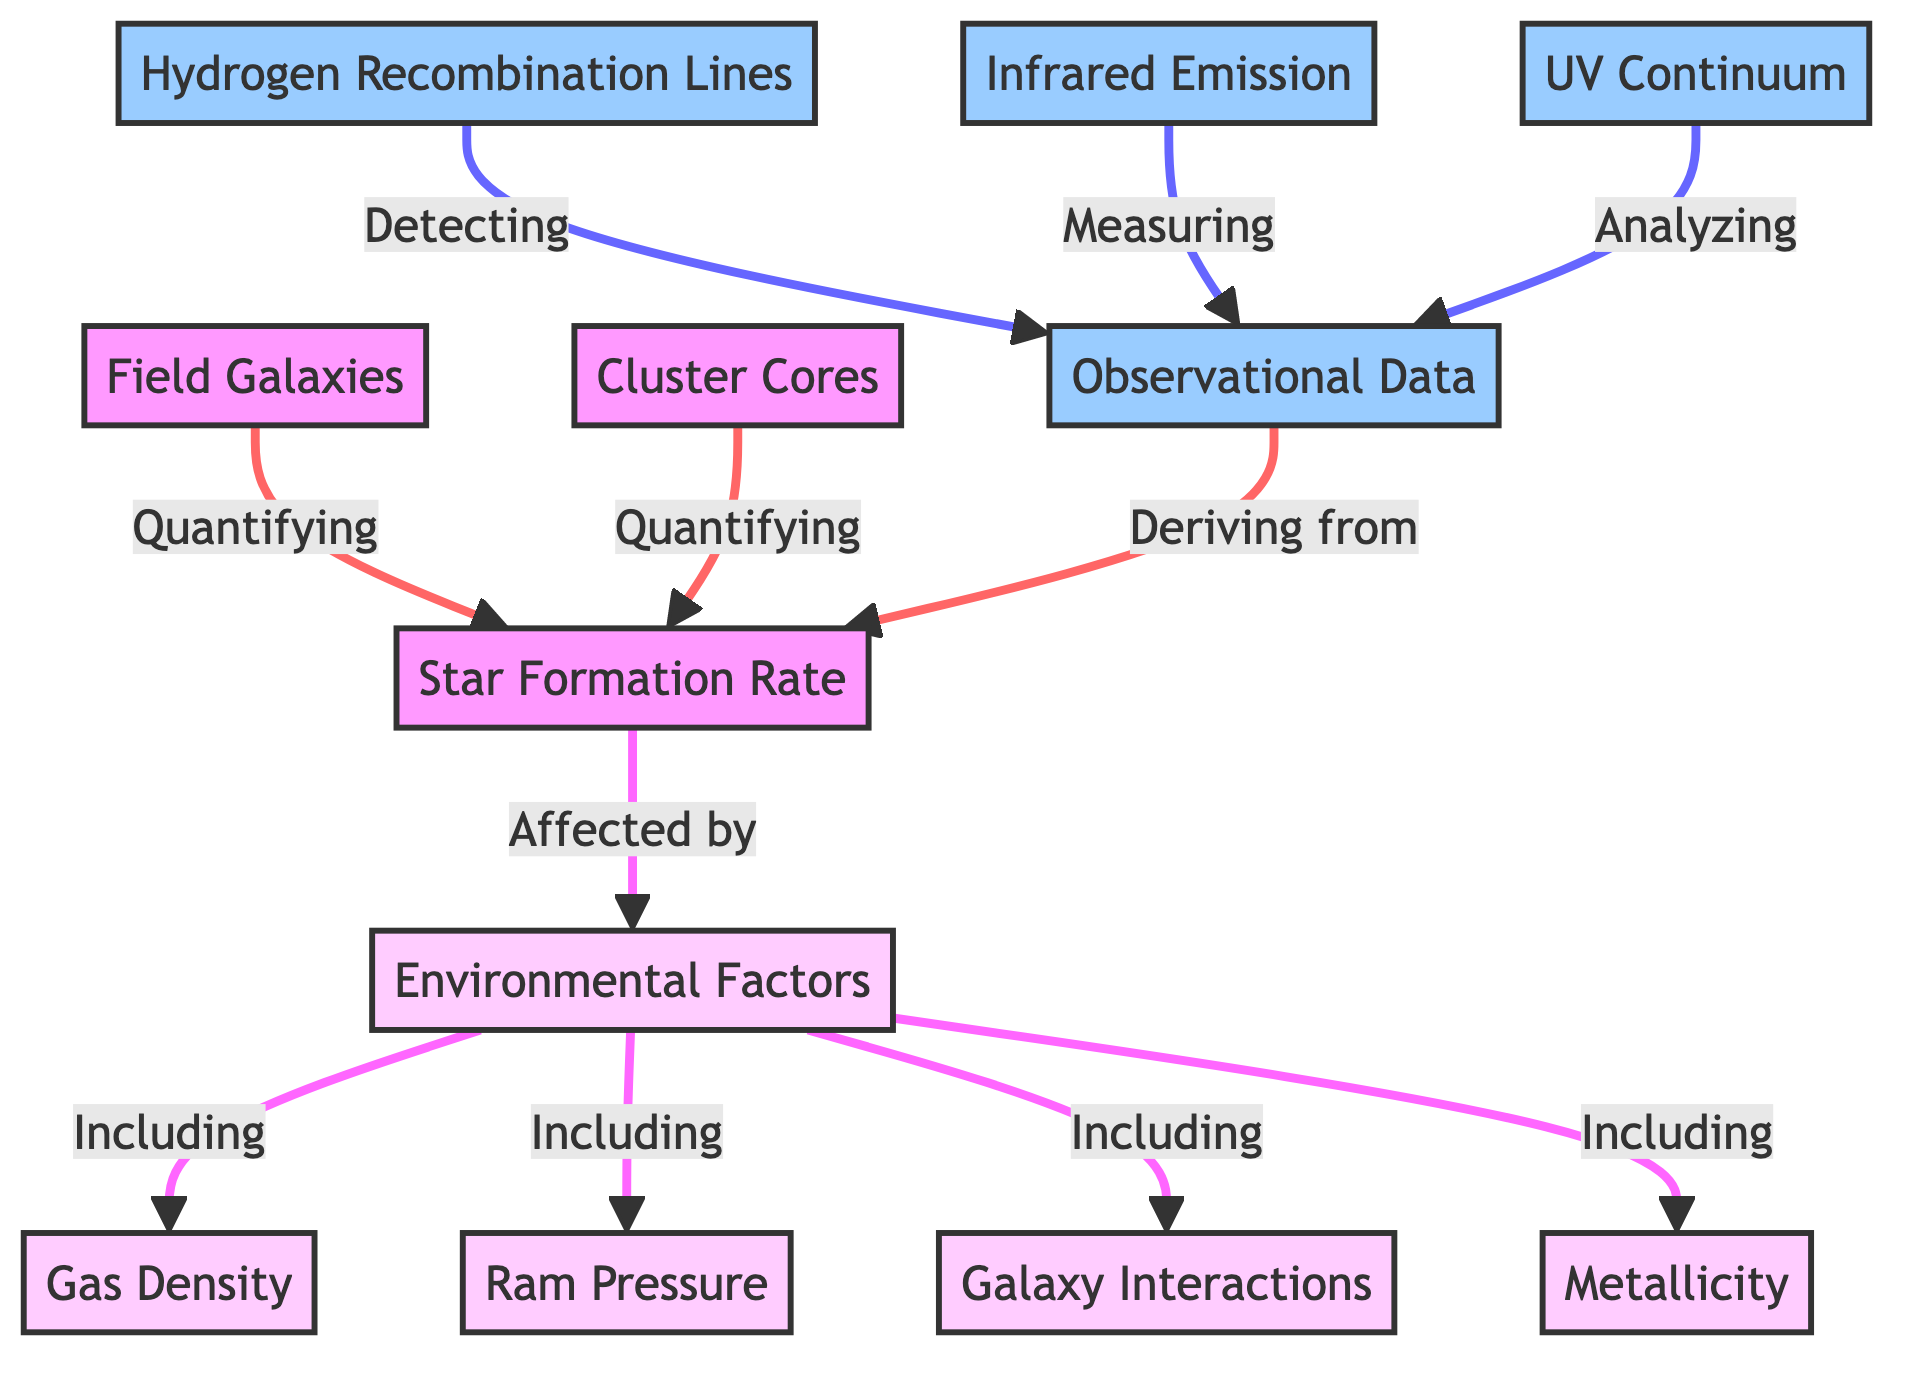What are the two main galaxy environments shown in the diagram? The diagram includes two main environments indicated by "Field Galaxies" and "Cluster Cores." These nodes represent the different galaxy environments being analyzed for star formation rates.
Answer: Field Galaxies, Cluster Cores How many observational data sources are contributing to the measurement of star formation rates? The diagram lists three observational data sources that contribute to measuring star formation rates: Hydrogen Recombination Lines, Infrared Emission, and UV Continuum. Counting these sources gives a total of three contributing nodes.
Answer: 3 What is the relationship between Environmental Factors and Star Formation Rate? The diagram shows that Star Formation Rate is affected by Environmental Factors, which is indicated by the arrow pointing from Environmental Factors to Star Formation Rate, signifying a direct influence.
Answer: Affected by Which environmental factor is related to gas density? In the diagram, the Environmental Factors node includes Gas Density as one of its components, indicating that it is directly related to the factors affecting star formation rates in galaxies.
Answer: Gas Density What does the observational data derived from in this diagram? The diagram indicates that the observational data is derived from the Star Formation Rate, represented by the relationship shown by the arrow between Star Formation Rate and Observational Data.
Answer: Star Formation Rate List one of the four environmental factors affecting star formation rates. The diagram clearly defines four environmental factors including Gas Density, Ram Pressure, Galaxy Interactions, and Metallicity. Any one of these can be the answer, based on the provided information.
Answer: Gas Density What are the three methods used to detect observational data? The methods used to detect observational data in the diagram are Hydrogen Recombination Lines, Infrared Emission, and UV Continuum, which are visually linked to the Observational Data node.
Answer: Hydrogen Recombination Lines, Infrared Emission, UV Continuum How does the diagram categorize the nodes related to observational processes? The diagram classifies the nodes related to observational processes with a specific color that denotes them as observational; they are colored light blue (indicated by `observational fill:#9cf,stroke:#333,stroke-width:2px`).
Answer: Observational (light blue) What is the significance of the flow arrows in this diagram? The flow arrows in the diagram dictate the directionality of influence or relationships between the different nodes, indicating that one aspect impacts or is connected to another, facilitating understanding of the data flow in the context of quantifying star formation rates.
Answer: Direction of influence 